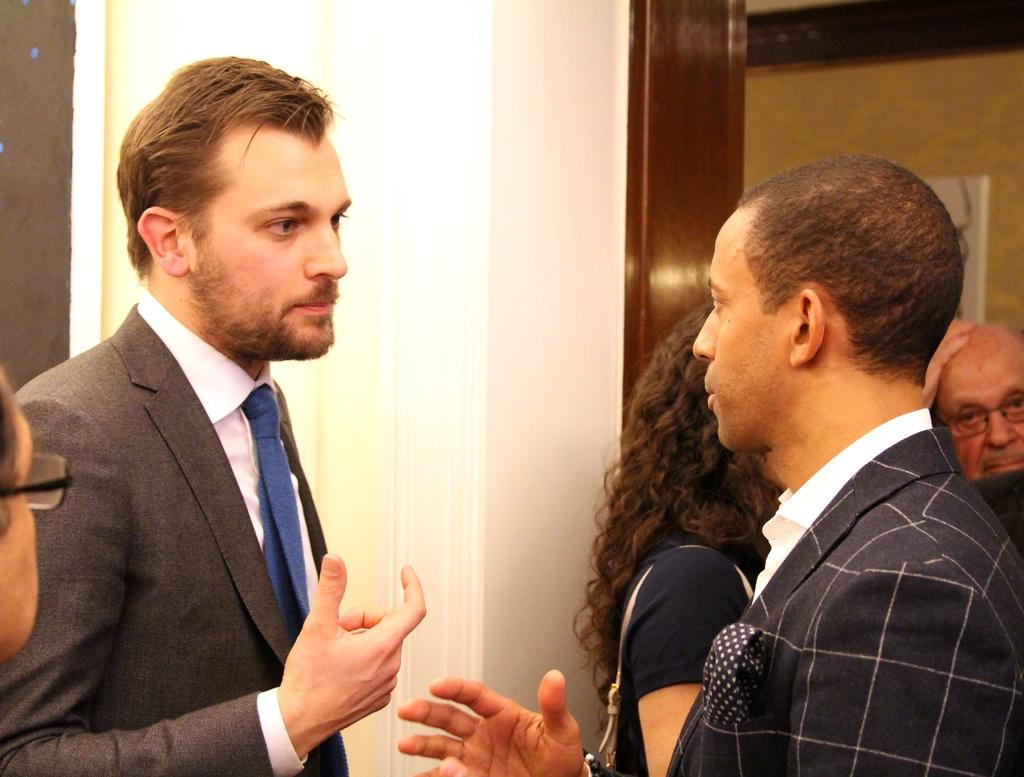What is the main subject of the image? The main subject of the image is a group of people. What can be seen in the background of the image? There is a pillar and a wall in the background of the image. What type of magic is being performed by the group of people in the image? There is no indication of magic or any magical activity in the image; it simply shows a group of people. 